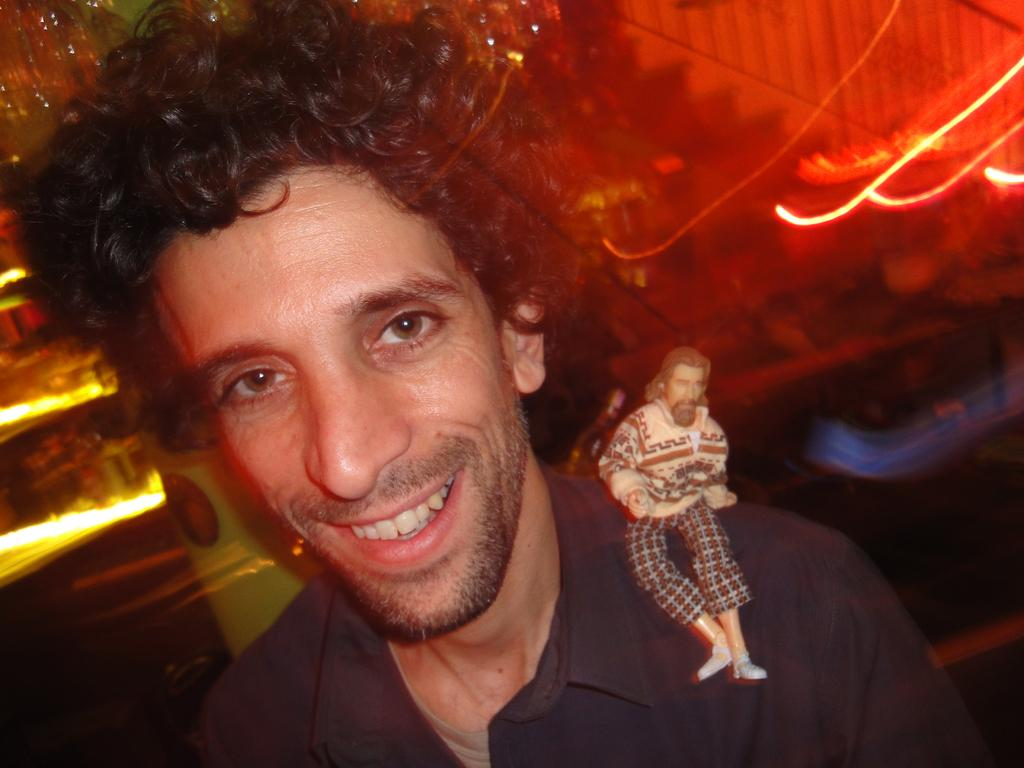Where was the image taken? The image was taken indoors. What is the main subject of the image? There is a man in the middle of the image. What is the man holding or wearing on his shoulder? The man has a toy of a man on his shoulder. What is the man's facial expression? The man is smiling. Who is the man's friend or partner in the image? There is no friend or partner present in the image; it only features the man with a toy on his shoulder. Can you see any bees in the image? There are no bees present in the image. 